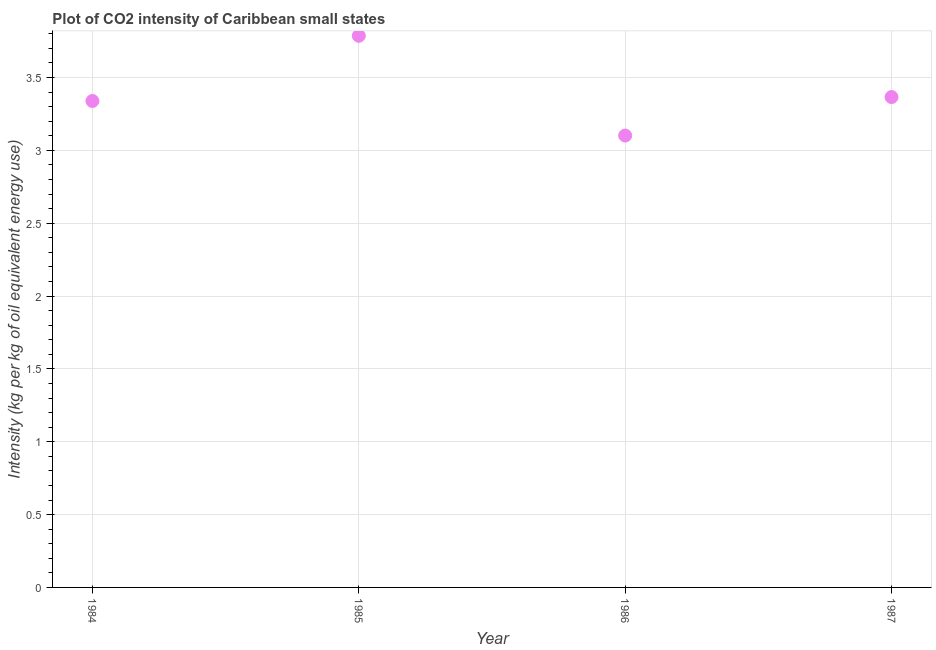What is the co2 intensity in 1984?
Offer a terse response. 3.34. Across all years, what is the maximum co2 intensity?
Offer a terse response. 3.79. Across all years, what is the minimum co2 intensity?
Your response must be concise. 3.1. In which year was the co2 intensity maximum?
Make the answer very short. 1985. What is the sum of the co2 intensity?
Offer a terse response. 13.59. What is the difference between the co2 intensity in 1986 and 1987?
Offer a very short reply. -0.26. What is the average co2 intensity per year?
Make the answer very short. 3.4. What is the median co2 intensity?
Your answer should be very brief. 3.35. In how many years, is the co2 intensity greater than 3.6 kg?
Offer a terse response. 1. Do a majority of the years between 1986 and 1985 (inclusive) have co2 intensity greater than 3 kg?
Ensure brevity in your answer.  No. What is the ratio of the co2 intensity in 1986 to that in 1987?
Keep it short and to the point. 0.92. Is the co2 intensity in 1985 less than that in 1986?
Your answer should be very brief. No. Is the difference between the co2 intensity in 1985 and 1986 greater than the difference between any two years?
Your response must be concise. Yes. What is the difference between the highest and the second highest co2 intensity?
Offer a terse response. 0.42. Is the sum of the co2 intensity in 1985 and 1986 greater than the maximum co2 intensity across all years?
Give a very brief answer. Yes. What is the difference between the highest and the lowest co2 intensity?
Your response must be concise. 0.68. Does the co2 intensity monotonically increase over the years?
Ensure brevity in your answer.  No. What is the difference between two consecutive major ticks on the Y-axis?
Make the answer very short. 0.5. Are the values on the major ticks of Y-axis written in scientific E-notation?
Provide a short and direct response. No. Does the graph contain grids?
Your answer should be very brief. Yes. What is the title of the graph?
Your answer should be very brief. Plot of CO2 intensity of Caribbean small states. What is the label or title of the X-axis?
Give a very brief answer. Year. What is the label or title of the Y-axis?
Provide a succinct answer. Intensity (kg per kg of oil equivalent energy use). What is the Intensity (kg per kg of oil equivalent energy use) in 1984?
Your response must be concise. 3.34. What is the Intensity (kg per kg of oil equivalent energy use) in 1985?
Your answer should be very brief. 3.79. What is the Intensity (kg per kg of oil equivalent energy use) in 1986?
Your answer should be very brief. 3.1. What is the Intensity (kg per kg of oil equivalent energy use) in 1987?
Offer a very short reply. 3.37. What is the difference between the Intensity (kg per kg of oil equivalent energy use) in 1984 and 1985?
Your answer should be very brief. -0.45. What is the difference between the Intensity (kg per kg of oil equivalent energy use) in 1984 and 1986?
Provide a succinct answer. 0.24. What is the difference between the Intensity (kg per kg of oil equivalent energy use) in 1984 and 1987?
Provide a short and direct response. -0.03. What is the difference between the Intensity (kg per kg of oil equivalent energy use) in 1985 and 1986?
Ensure brevity in your answer.  0.68. What is the difference between the Intensity (kg per kg of oil equivalent energy use) in 1985 and 1987?
Make the answer very short. 0.42. What is the difference between the Intensity (kg per kg of oil equivalent energy use) in 1986 and 1987?
Your answer should be compact. -0.26. What is the ratio of the Intensity (kg per kg of oil equivalent energy use) in 1984 to that in 1985?
Give a very brief answer. 0.88. What is the ratio of the Intensity (kg per kg of oil equivalent energy use) in 1984 to that in 1986?
Give a very brief answer. 1.08. What is the ratio of the Intensity (kg per kg of oil equivalent energy use) in 1984 to that in 1987?
Keep it short and to the point. 0.99. What is the ratio of the Intensity (kg per kg of oil equivalent energy use) in 1985 to that in 1986?
Your answer should be compact. 1.22. What is the ratio of the Intensity (kg per kg of oil equivalent energy use) in 1986 to that in 1987?
Your answer should be compact. 0.92. 